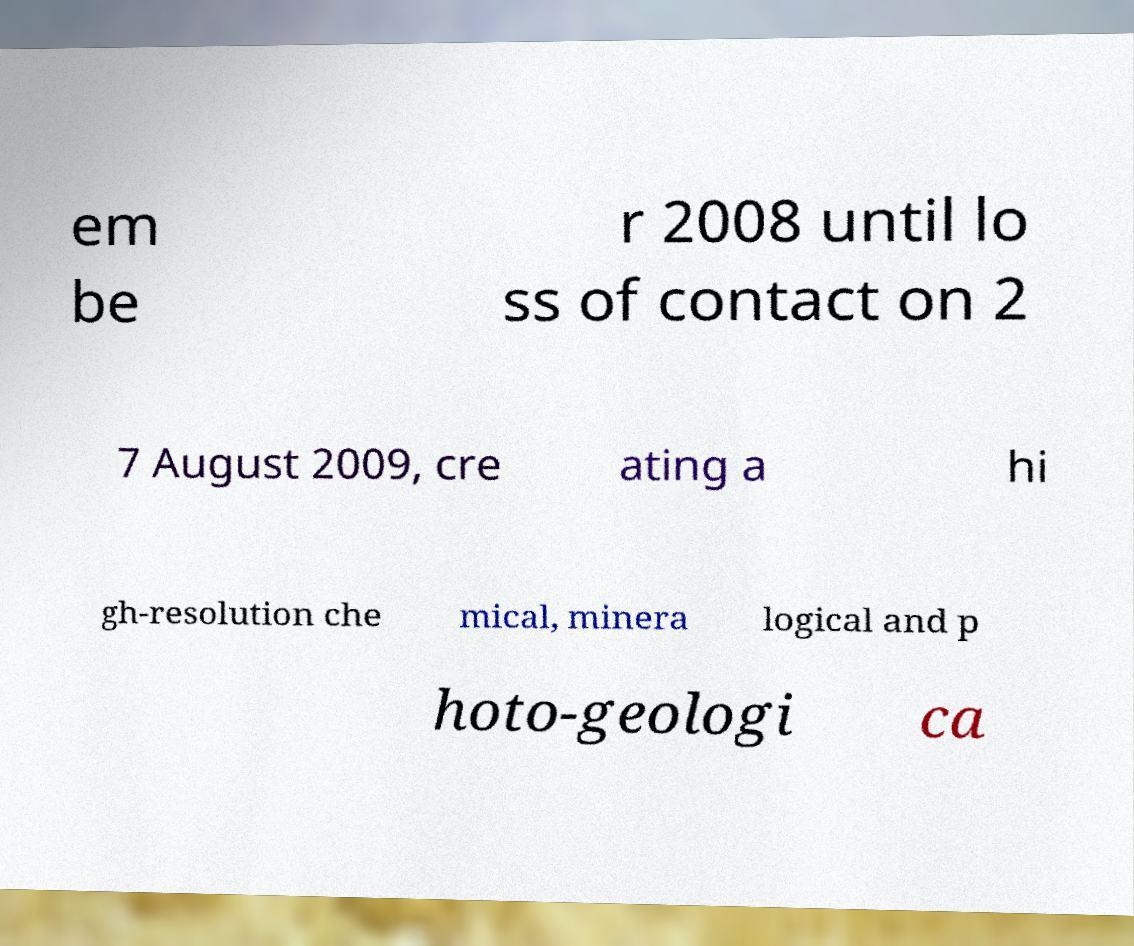What messages or text are displayed in this image? I need them in a readable, typed format. em be r 2008 until lo ss of contact on 2 7 August 2009, cre ating a hi gh-resolution che mical, minera logical and p hoto-geologi ca 